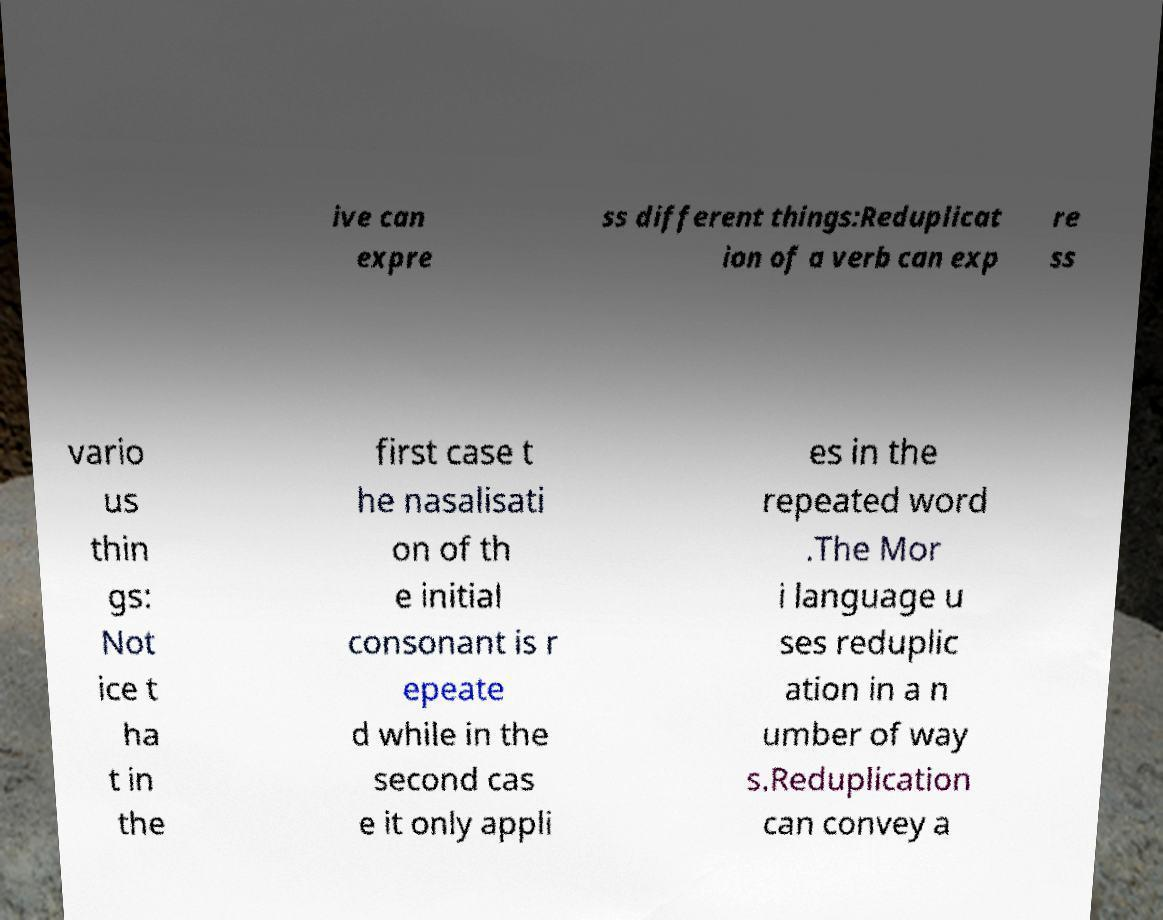I need the written content from this picture converted into text. Can you do that? ive can expre ss different things:Reduplicat ion of a verb can exp re ss vario us thin gs: Not ice t ha t in the first case t he nasalisati on of th e initial consonant is r epeate d while in the second cas e it only appli es in the repeated word .The Mor i language u ses reduplic ation in a n umber of way s.Reduplication can convey a 